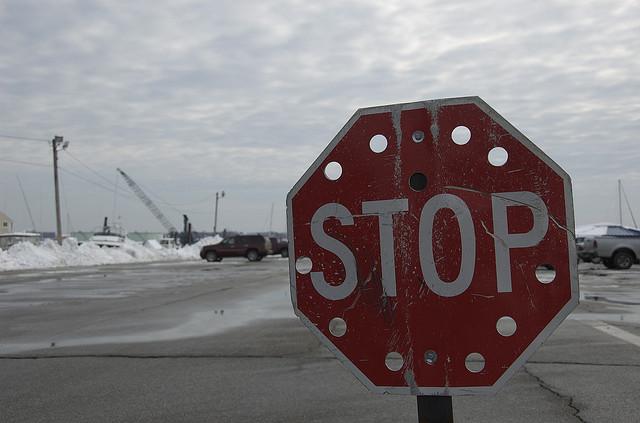Is there more than one hole in the stop sign?
Concise answer only. Yes. How did the holes get on the stop sign?
Be succinct. Drill. What kind of vehicle is to the left of the sign?
Concise answer only. Suv. 